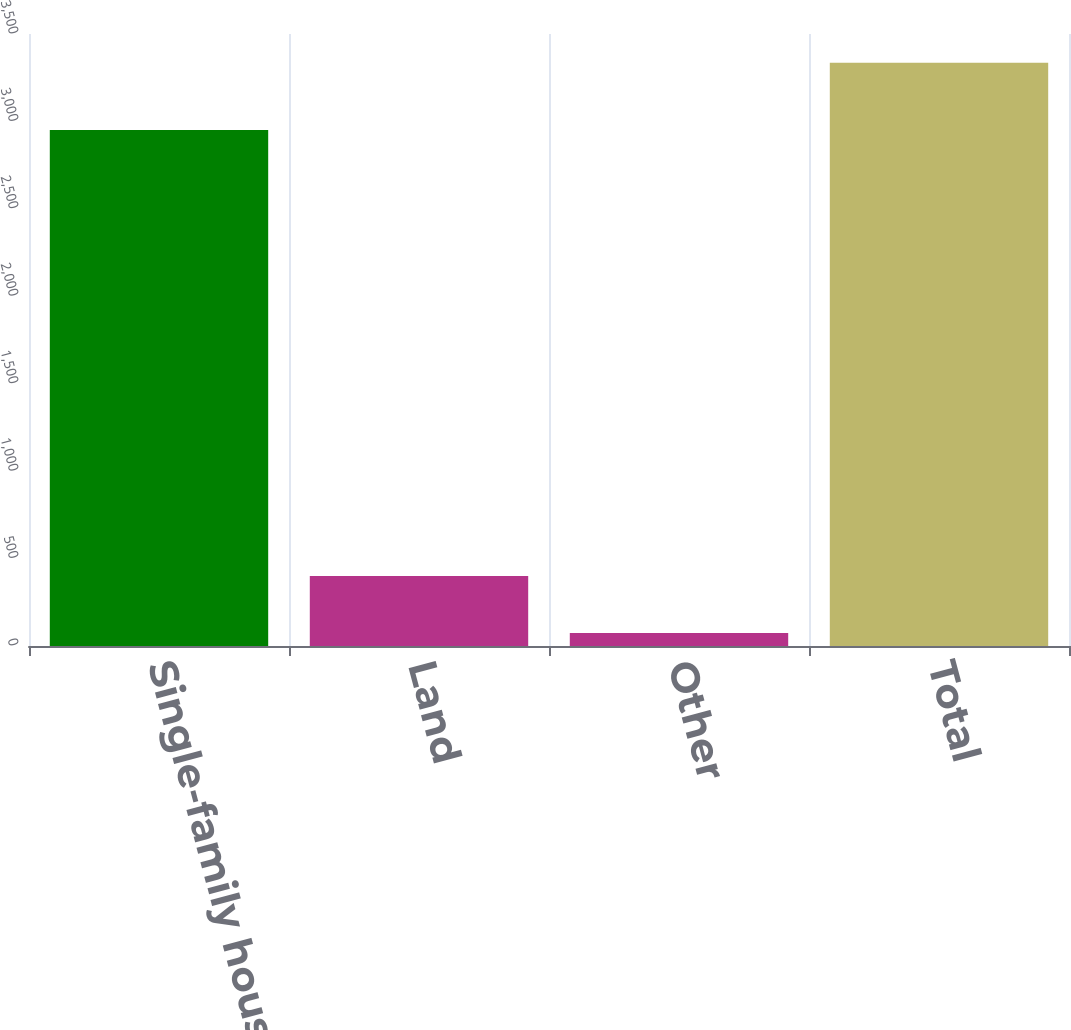Convert chart. <chart><loc_0><loc_0><loc_500><loc_500><bar_chart><fcel>Single-family housing<fcel>Land<fcel>Other<fcel>Total<nl><fcel>2951<fcel>400.1<fcel>74<fcel>3335<nl></chart> 